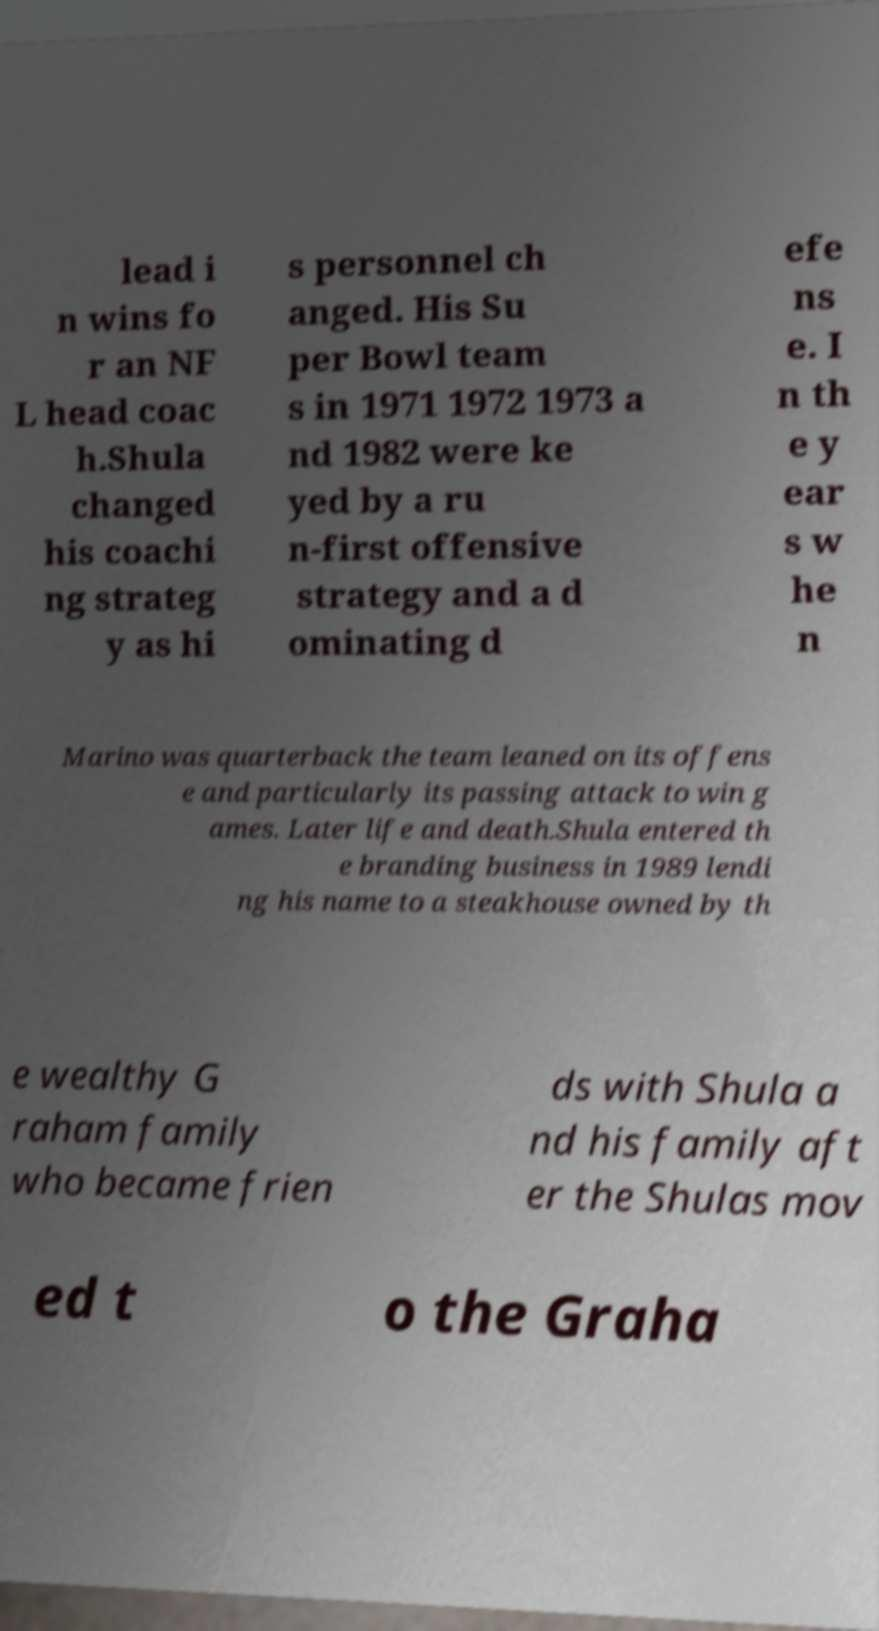For documentation purposes, I need the text within this image transcribed. Could you provide that? lead i n wins fo r an NF L head coac h.Shula changed his coachi ng strateg y as hi s personnel ch anged. His Su per Bowl team s in 1971 1972 1973 a nd 1982 were ke yed by a ru n-first offensive strategy and a d ominating d efe ns e. I n th e y ear s w he n Marino was quarterback the team leaned on its offens e and particularly its passing attack to win g ames. Later life and death.Shula entered th e branding business in 1989 lendi ng his name to a steakhouse owned by th e wealthy G raham family who became frien ds with Shula a nd his family aft er the Shulas mov ed t o the Graha 